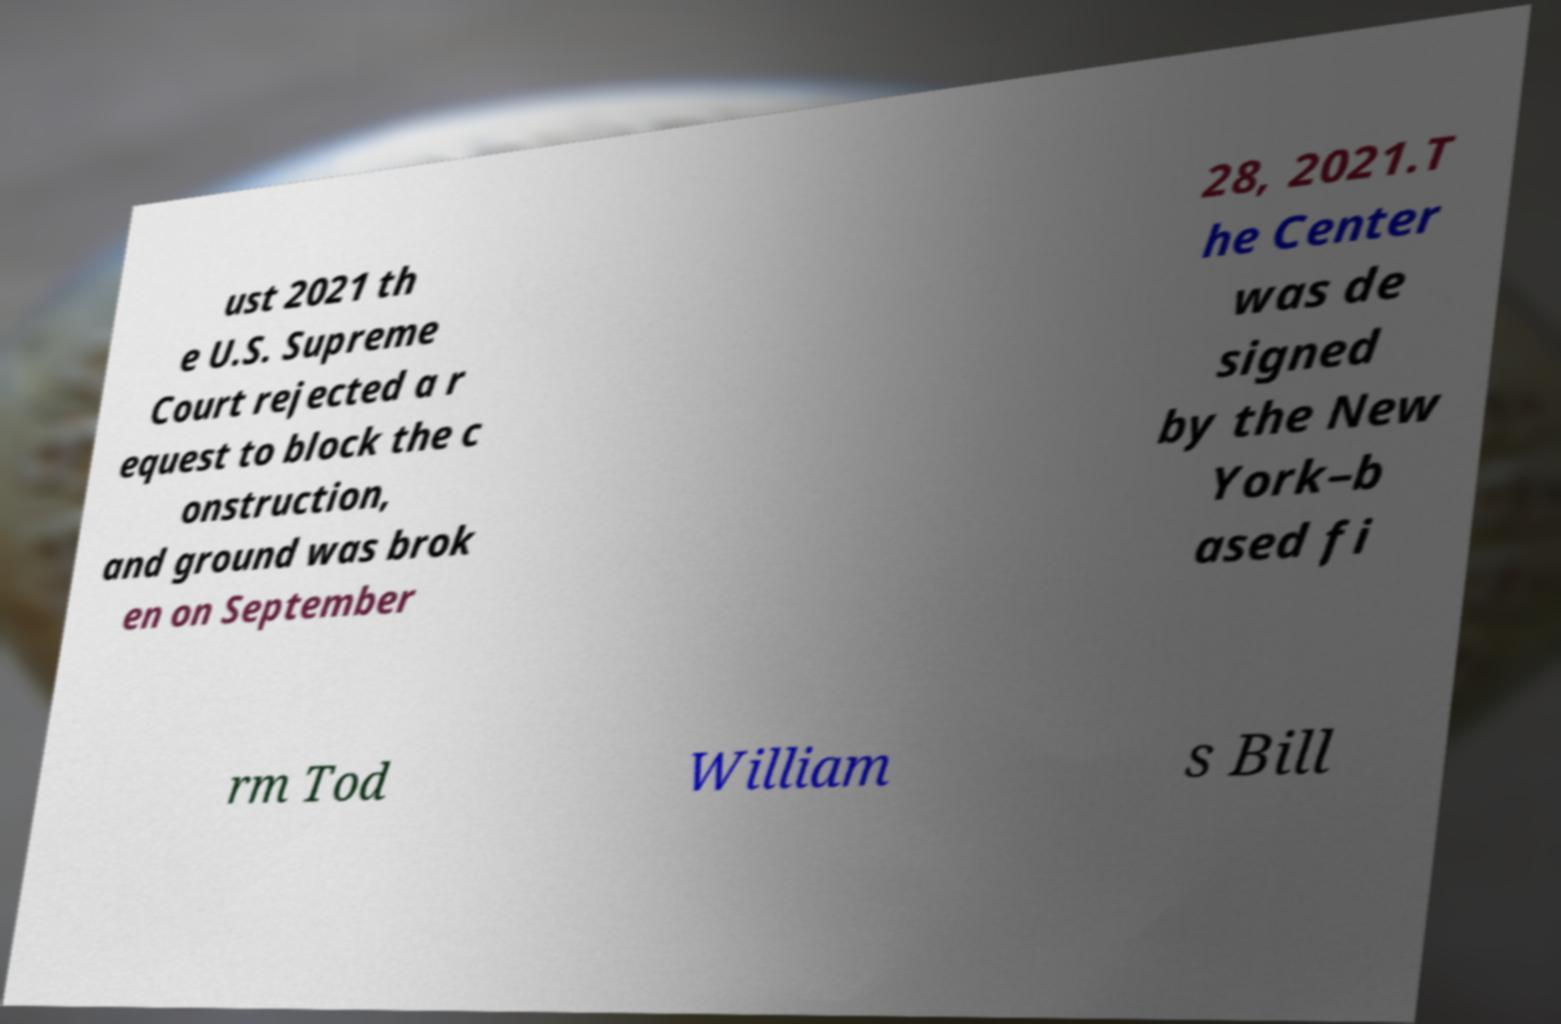Can you read and provide the text displayed in the image?This photo seems to have some interesting text. Can you extract and type it out for me? ust 2021 th e U.S. Supreme Court rejected a r equest to block the c onstruction, and ground was brok en on September 28, 2021.T he Center was de signed by the New York–b ased fi rm Tod William s Bill 